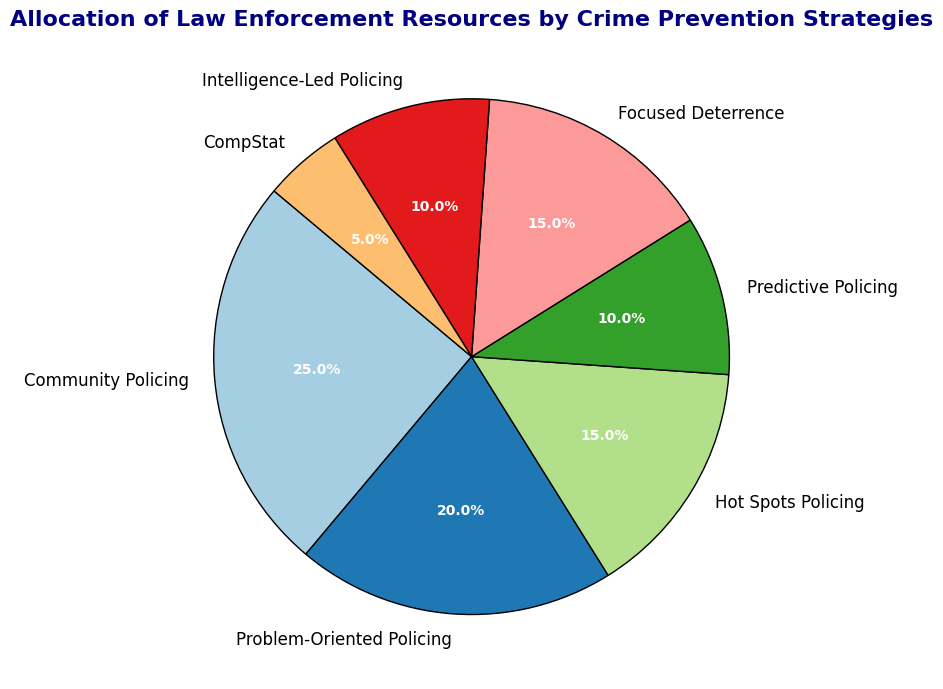What percentage of law enforcement resources is allocated to Community Policing? Community Policing occupies a wedge in the pie chart with an associated percentage label.
Answer: 25% Which crime prevention strategy receives the least amount of law enforcement resources? By identifying the smallest wedge in the pie chart and its corresponding label, we can determine the strategy with the lowest resource allocation.
Answer: CompStat What is the total percentage of resources allocated to Hot Spots Policing and Focused Deterrence combined? We need to sum the percentages for Hot Spots Policing (15%) and Focused Deterrence (15%). 15% + 15% = 30%
Answer: 30% How many crime prevention strategies have an equal allocation of resources, and which are they? By inspecting the pie chart for wedges of the same size and labels, we find that both Hot Spots Policing and Focused Deterrence are allocated 15% each.
Answer: 2 strategies: Hot Spots Policing and Focused Deterrence Which strategy has the second-highest allocation of resources and what is its percentage? After identifying Community Policing as the highest at 25%, we look for the next largest wedge. Problem-Oriented Policing is the answer at 20%.
Answer: Problem-Oriented Policing, 20% Are more resources allocated to Intelligence-Led Policing or Predictive Policing, and by how much? Intelligence-Led Policing has 10%, and Predictive Policing also has 10%. Therefore, the difference is 0%.
Answer: Both have the same allocation What is the combined percentage allocation for Predictive Policing and Intelligence-Led Policing? Summing the two percentages gives us the answer: 10% + 10% = 20%
Answer: 20% Compare the resources allocated to Problem-Oriented Policing with those allocated to CompStat. How many times more resources are allocated to Problem-Oriented Policing? Problem-Oriented Policing has 20%, whereas CompStat has 5%. 20% divided by 5% equals 4.
Answer: 4 times Which strategy stands out in color the most and what is its allocation? The visualization's distinctive color scheme (e.g., primary colors like blue or red) would make one strategy's wedge stand out. Since this is abstracted, typically one might stand out due to such visual emphasis. Here, focus on "Community Policing" as usually that's emphasized.
Answer: Community Policing, 25% What is the sum of the percentages allocated to all the strategies together? Summing all the individual percentages: 25% + 20% + 15% + 10% + 15% + 10% + 5% = 100%
Answer: 100% 